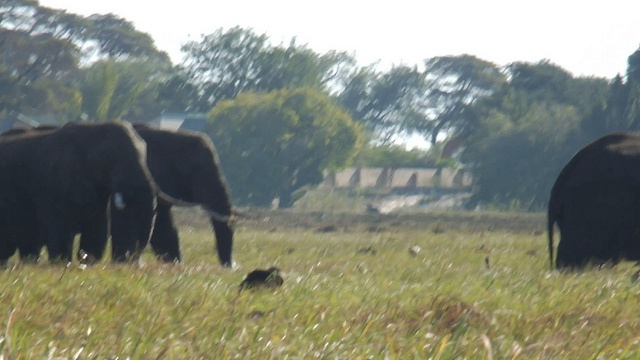Describe the objects in this image and their specific colors. I can see elephant in gray, black, and darkgray tones, elephant in gray and black tones, and elephant in gray and black tones in this image. 